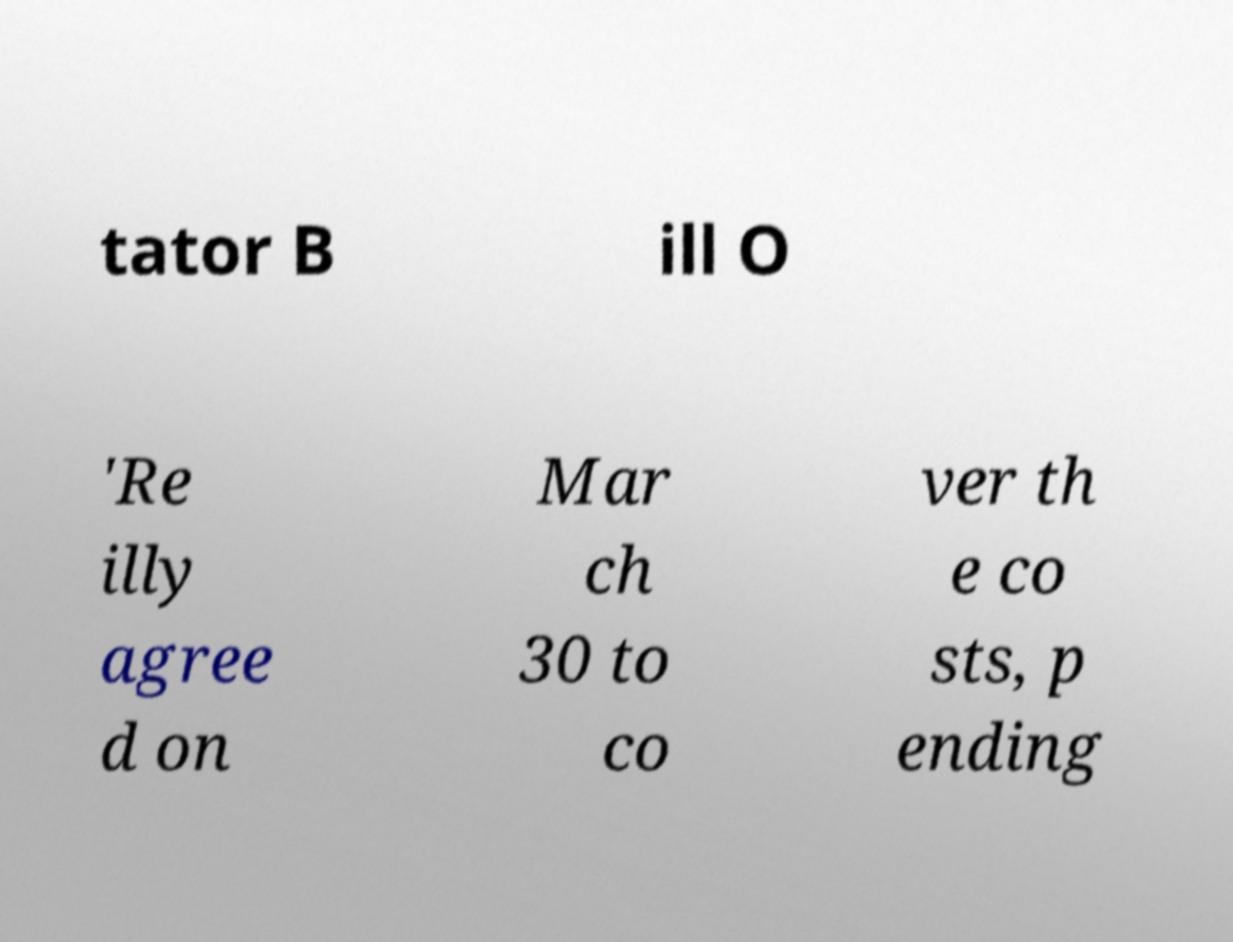For documentation purposes, I need the text within this image transcribed. Could you provide that? tator B ill O 'Re illy agree d on Mar ch 30 to co ver th e co sts, p ending 